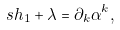<formula> <loc_0><loc_0><loc_500><loc_500>s h _ { 1 } + \lambda = \partial _ { k } \alpha ^ { k } ,</formula> 